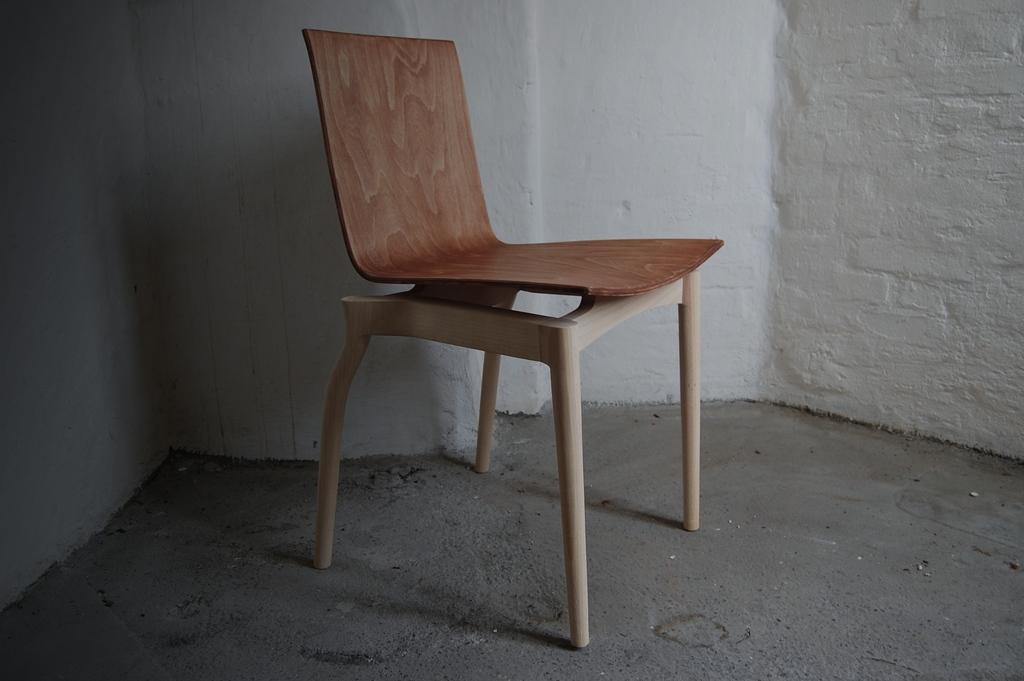What piece of furniture is present in the image? There is a chair in the image. Where is the chair located in relation to the wall? The chair is in front of a wall. What type of lace is draped over the chair in the image? There is no lace present in the image; only the chair and the wall are visible. 